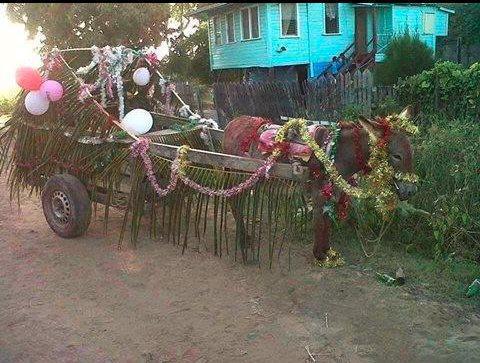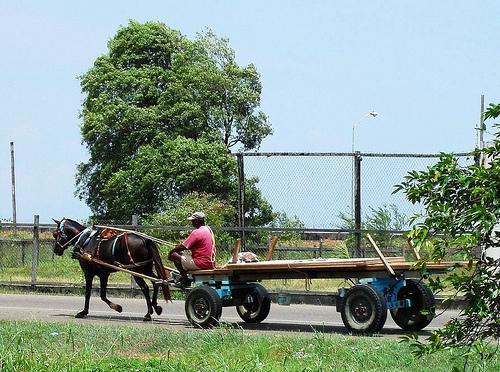The first image is the image on the left, the second image is the image on the right. For the images displayed, is the sentence "The right image shows one animal pulling a wagon with four wheels in a leftward direction." factually correct? Answer yes or no. Yes. 